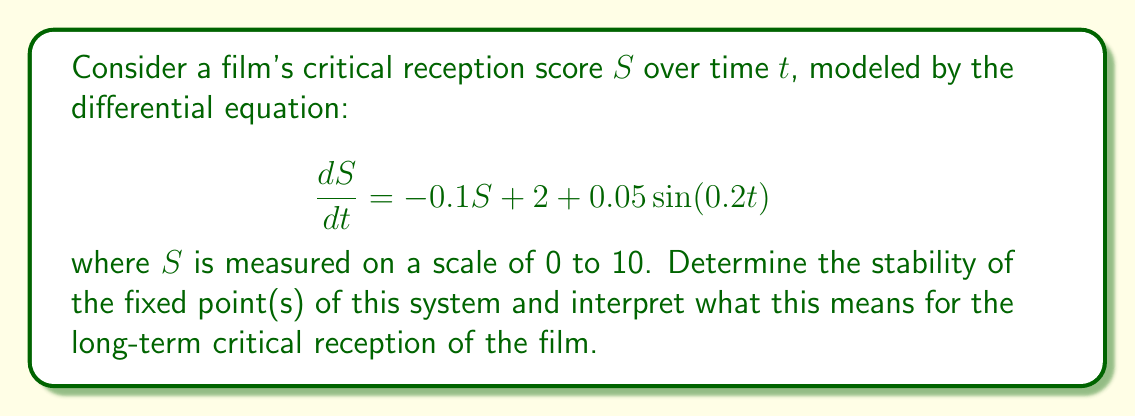Solve this math problem. 1) First, we need to find the fixed point(s) of the system. At a fixed point, $\frac{dS}{dt} = 0$. However, our system has a time-dependent term. We'll consider the average behavior by ignoring the sinusoidal term:

   $$0 = -0.1S + 2$$
   $$0.1S = 2$$
   $$S^* = 20$$

2) The fixed point $S^* = 20$ is outside our scale of 0 to 10, but it still influences the system's behavior.

3) To determine stability, we examine the derivative of $\frac{dS}{dt}$ with respect to $S$ at the fixed point:

   $$\frac{d}{dS}(\frac{dS}{dt}) = -0.1$$

4) Since this derivative is negative, the fixed point is stable. The system will tend towards this fixed point, but will never reach it due to the scale limitations and the oscillating term.

5) The oscillating term $0.05\sin(0.2t)$ will cause small fluctuations around the equilibrium point, but won't change the overall stability.

6) Interpreting this for the film's critical reception:
   - The film's score will tend towards the maximum of the scale (10) over time.
   - There will be small oscillations in the score due to changing critic opinions or new reviews.
   - The score will stabilize near the top of the scale but never quite reach 10 due to the oscillations.

This mirrors a scenario where a director's film is generally well-received and its reputation improves over time, with minor fluctuations due to changing critical perspectives.
Answer: Stable fixed point at $S^* = 20$ (outside scale); score tends towards 10 with small oscillations. 